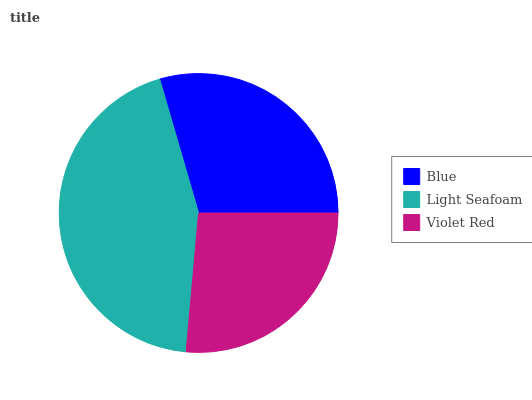Is Violet Red the minimum?
Answer yes or no. Yes. Is Light Seafoam the maximum?
Answer yes or no. Yes. Is Light Seafoam the minimum?
Answer yes or no. No. Is Violet Red the maximum?
Answer yes or no. No. Is Light Seafoam greater than Violet Red?
Answer yes or no. Yes. Is Violet Red less than Light Seafoam?
Answer yes or no. Yes. Is Violet Red greater than Light Seafoam?
Answer yes or no. No. Is Light Seafoam less than Violet Red?
Answer yes or no. No. Is Blue the high median?
Answer yes or no. Yes. Is Blue the low median?
Answer yes or no. Yes. Is Violet Red the high median?
Answer yes or no. No. Is Violet Red the low median?
Answer yes or no. No. 